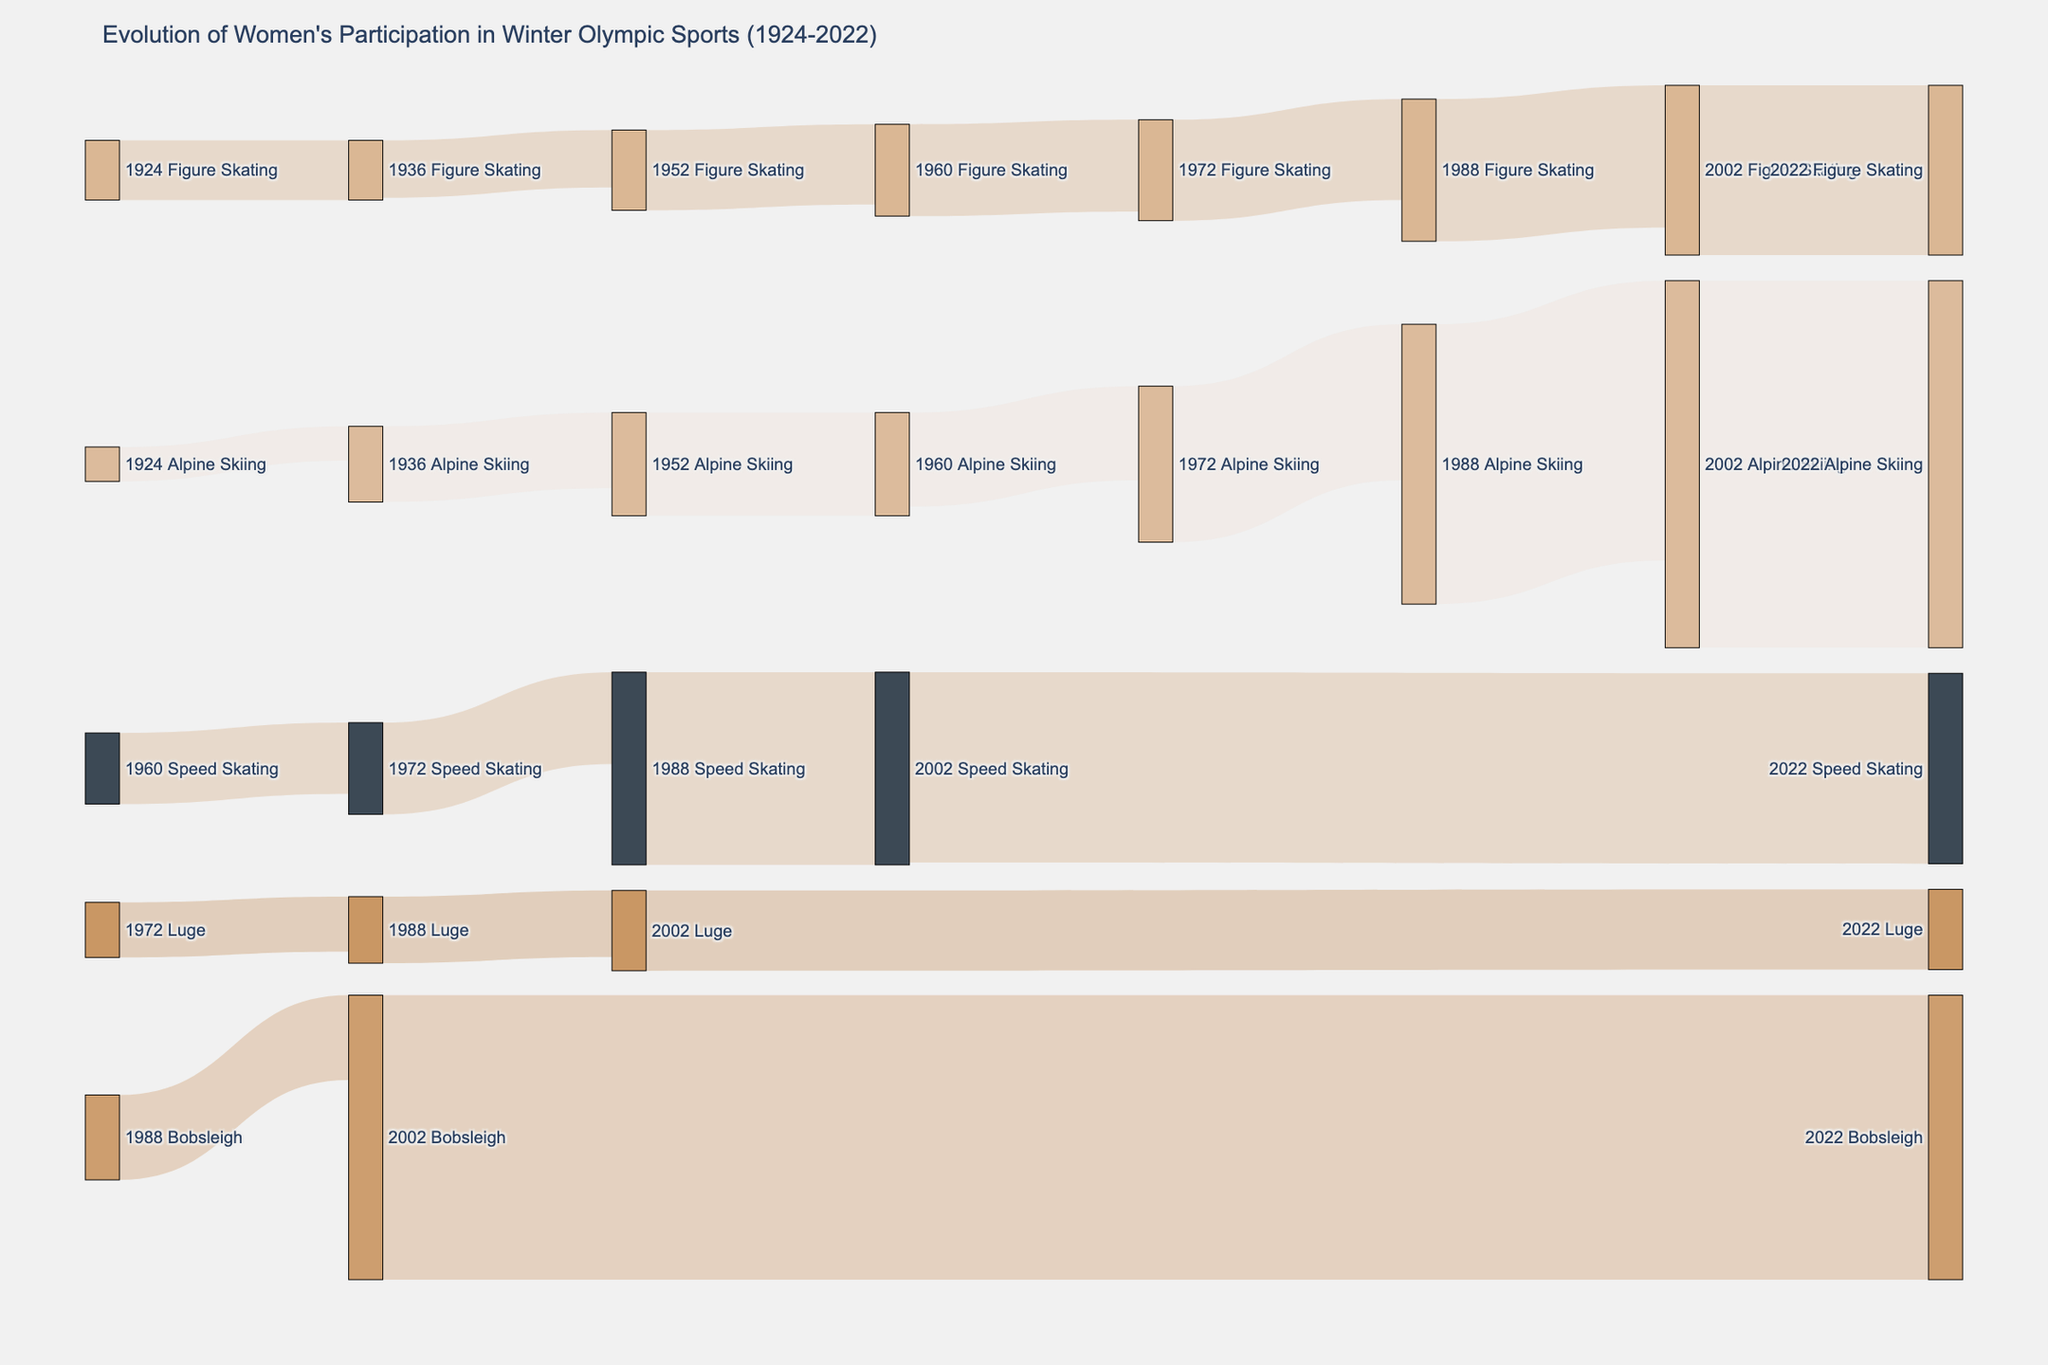what is the title of the figure? The title is located at the top of the figure. It represents the overarching topic that the Sankey diagram depicts, namely the evolution of women's participation in Winter Olympic sports over time.
Answer: Evolution of Women's Participation in Winter Olympic Sports (1924-2022) How many sports were there for women in the Winter Olympics in 1924? By examining the nodes labeled with the year 1924, one can count that there are only two nodes for sports, indicating the number of sports women participated in during that year.
Answer: 2 By what percentage did female participation in Alpine Skiing increase from 1924 to 2022? First, identify the number of participants in Alpine Skiing in 1924 (0) and in 2022 (160). Since there were no participants in 1924, this can be interpreted as a purely qualitative increase. The exact percentage increase from zero is technically undefined.
Answer: Undefined, but there was a qualitative increase from 0 to 160 participants Which sport saw the highest number of participants in 2022? Look at the nodes connected to the year 2022 and compare the numbers associated with each sport. The sport with the highest number is Alpine Skiing with 160 participants.
Answer: Alpine Skiing How did the number of participants in Bobsleigh change from 1988 to 2022? Examine the participants in 1988 and 2022 for Bobsleigh. The number goes from 0 in 1988 to 124 in 2022, indicating an increase in participation.
Answer: Increased by 124 Which sport made its debut for women's participation in 1960 according to the diagram? Cross-referencing the sports listed for 1960 with previous years, Speed Skating appears for the first time in 1960 with 27 participants.
Answer: Speed Skating Can you compare the number of female participants in Figure Skating between 1924 and 2022? Reference the participant numbers for Figure Skating in 1924 (11 participants) and 2022 (74 participants). Calculate the increase by subtracting the former from the latter.
Answer: Increased by 63 Which sport(s) have seen a consistent increase in female participation from their introduction until 2022? By tracing each sport's nodes over the years, you can observe that sports like Figure Skating and Alpine Skiing have shown a steady increase in participants from their introduction to 2022.
Answer: Figure Skating and Alpine Skiing In which year did women's Luge see its highest number of participants and what was that number? Examine the participant numbers for Luge across all years. The highest number is 35 participants in 2022.
Answer: 2022, 35 participants 